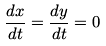<formula> <loc_0><loc_0><loc_500><loc_500>\frac { d x } { d t } = \frac { d y } { d t } = 0</formula> 